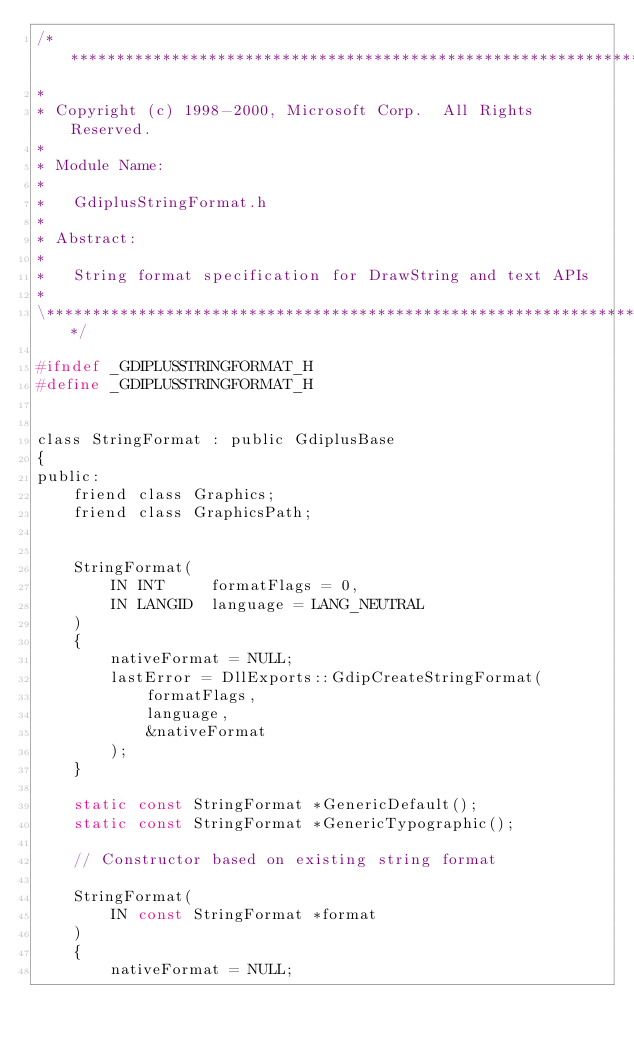<code> <loc_0><loc_0><loc_500><loc_500><_C_>/**************************************************************************\
*
* Copyright (c) 1998-2000, Microsoft Corp.  All Rights Reserved.
*
* Module Name:
*
*   GdiplusStringFormat.h
*
* Abstract:
*
*   String format specification for DrawString and text APIs
*
\**************************************************************************/

#ifndef _GDIPLUSSTRINGFORMAT_H
#define _GDIPLUSSTRINGFORMAT_H


class StringFormat : public GdiplusBase
{
public:
    friend class Graphics;
    friend class GraphicsPath;


    StringFormat(
        IN INT     formatFlags = 0,
        IN LANGID  language = LANG_NEUTRAL
    )
    {
        nativeFormat = NULL;
        lastError = DllExports::GdipCreateStringFormat(
            formatFlags,
            language,
            &nativeFormat
        );
    }

    static const StringFormat *GenericDefault();
    static const StringFormat *GenericTypographic();

    // Constructor based on existing string format

    StringFormat(
        IN const StringFormat *format
    )
    {
        nativeFormat = NULL;</code> 